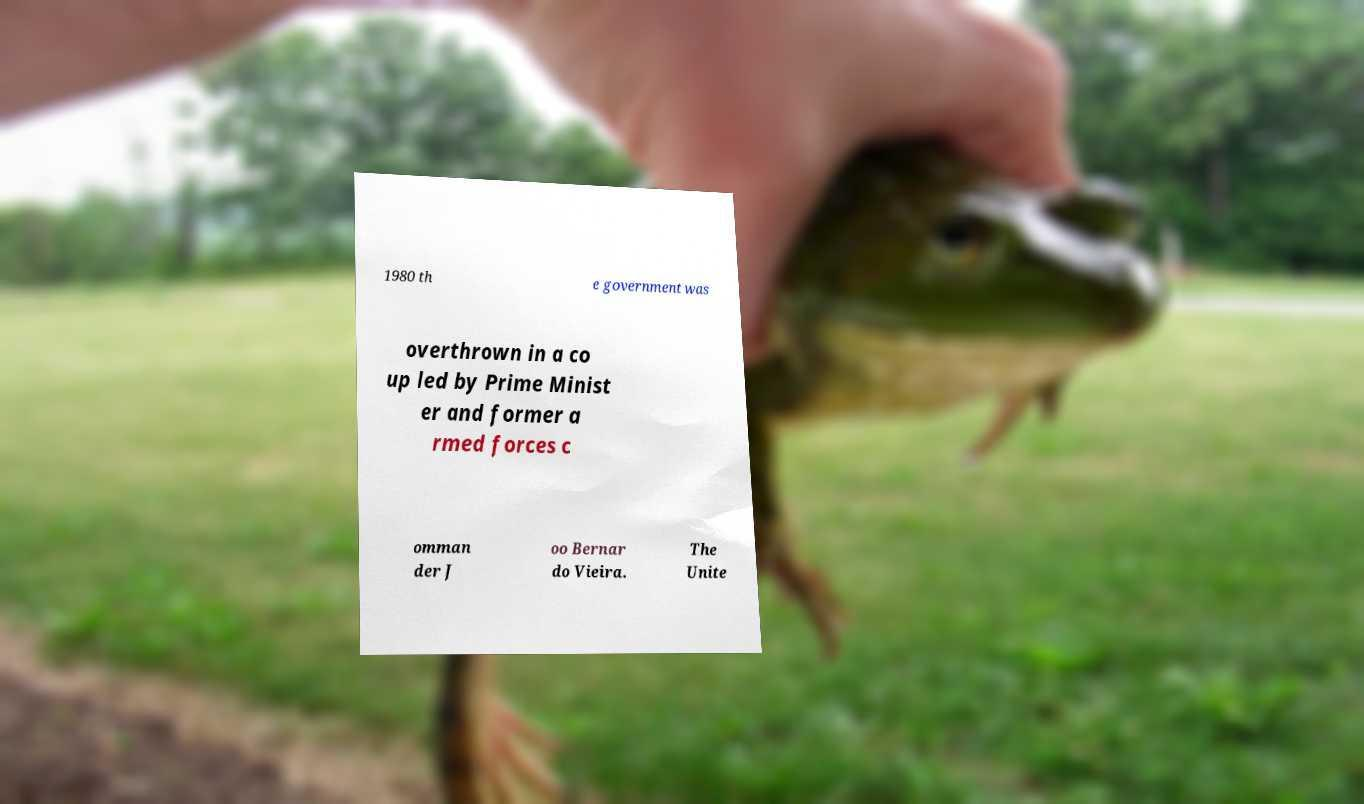Can you read and provide the text displayed in the image?This photo seems to have some interesting text. Can you extract and type it out for me? 1980 th e government was overthrown in a co up led by Prime Minist er and former a rmed forces c omman der J oo Bernar do Vieira. The Unite 